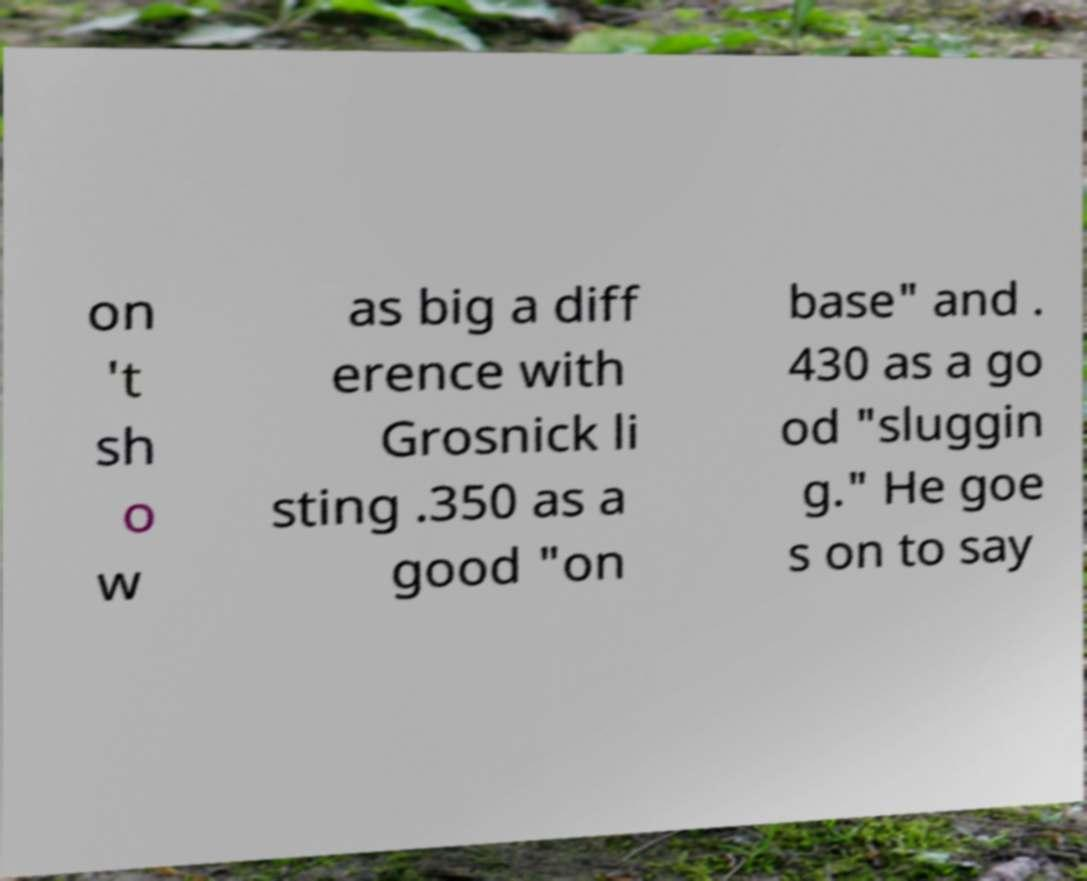What messages or text are displayed in this image? I need them in a readable, typed format. on 't sh o w as big a diff erence with Grosnick li sting .350 as a good "on base" and . 430 as a go od "sluggin g." He goe s on to say 